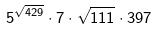<formula> <loc_0><loc_0><loc_500><loc_500>5 ^ { \sqrt { 4 2 9 } } \cdot 7 \cdot \sqrt { 1 1 1 } \cdot 3 9 7</formula> 